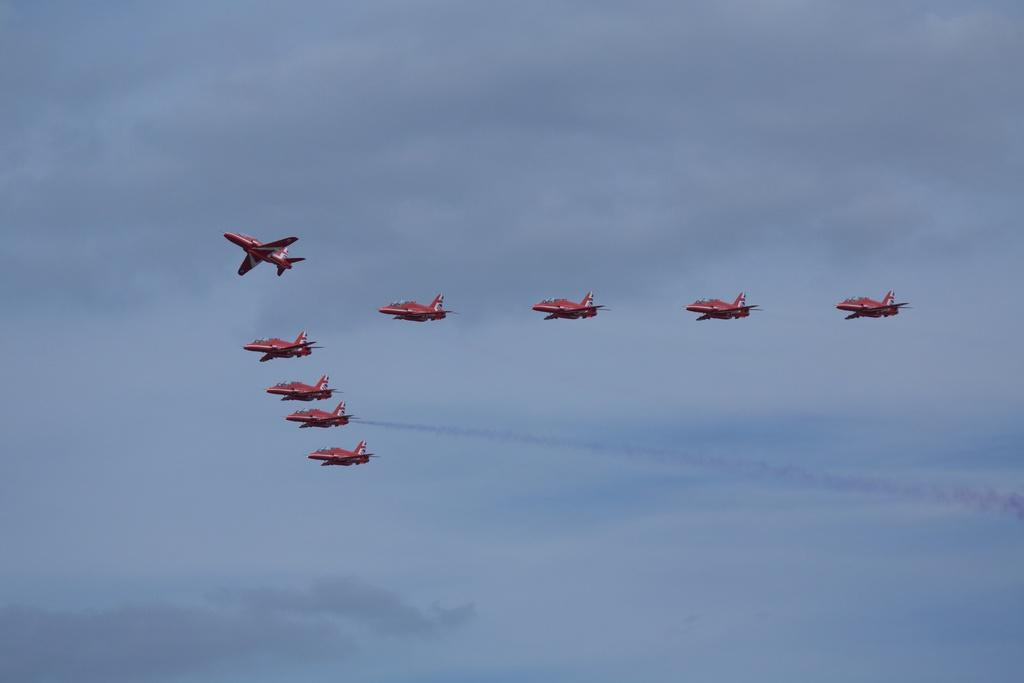What is the main subject of the image? The main subject of the image is aircraft. What are the aircraft doing in the image? The aircraft are flying in the sky. What type of smell can be detected from the aircraft in the image? There is no information about smells in the image, as it only shows aircraft flying in the sky. 